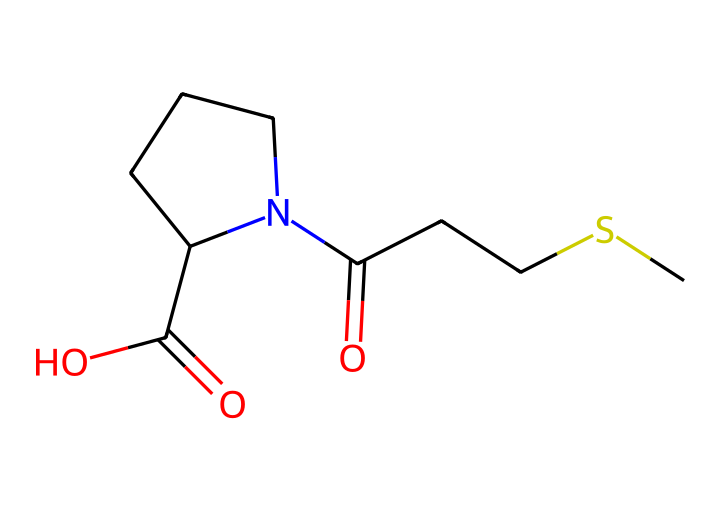What is the total number of carbon atoms in this structure? By analyzing the SMILES representation, we can count the number of 'C' in the series. There are a total of 7 carbon atoms present in the chemical structure.
Answer: seven How many nitrogen atoms are in this compound? The SMILES notation contains one 'N', indicating there is a single nitrogen atom present in the chemical structure.
Answer: one What functional groups are present in this antibiotic? Looking at the structure, we can identify a carboxylic acid functional group (due to the presence of -COOH) and an amide functional group (due to the -C(=O)N-). Thus, the chemical contains both a carboxylic acid and an amide group.
Answer: carboxylic acid and amide What type of bond connects the sulfur atom to the carbon chain? Observing the SMILES, we see the sulfur is attached to a carbon chain via a single bond (indicated by no special symbols between S and C). Therefore, it's a sigma bond.
Answer: sigma bond How does the presence of sulfur affect the antibiotic's activity? The presence of sulfur can influence the chemical’s reactivity and stability, which are crucial for its antibacterial properties, affecting how the drug interacts with target sites in bacteria.
Answer: enhances reactivity What is the significance of the cyclic structure in the molecule? The cyclic portion of the structure (represented by "N1CCCC1") contributes to the overall stability and specific interaction with bacterial targets, which can enhance the antibiotic's effectiveness.
Answer: enhances stability 